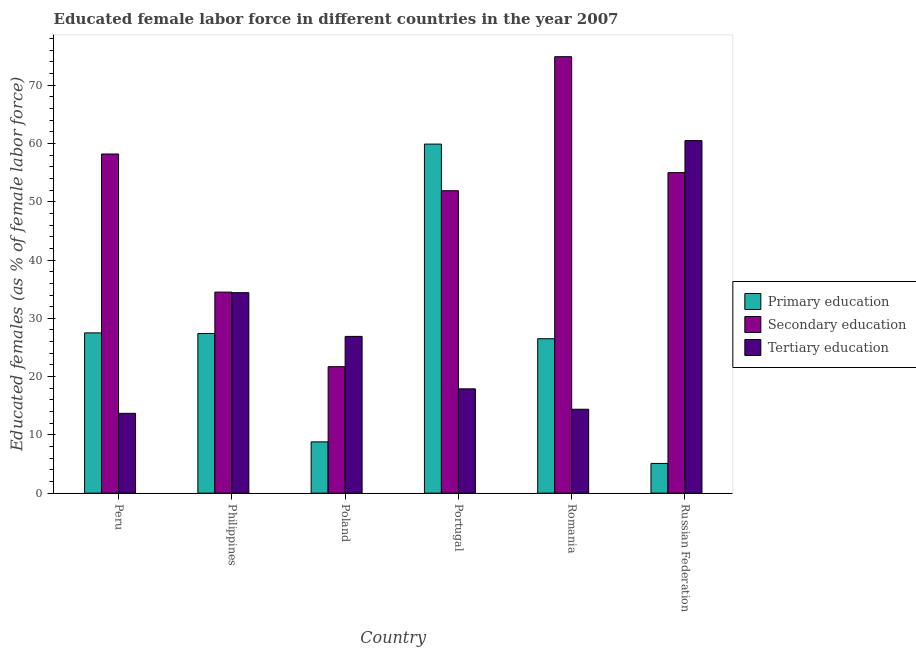Are the number of bars per tick equal to the number of legend labels?
Make the answer very short. Yes. Are the number of bars on each tick of the X-axis equal?
Keep it short and to the point. Yes. How many bars are there on the 5th tick from the right?
Make the answer very short. 3. What is the label of the 2nd group of bars from the left?
Provide a succinct answer. Philippines. What is the percentage of female labor force who received primary education in Philippines?
Your answer should be very brief. 27.4. Across all countries, what is the maximum percentage of female labor force who received secondary education?
Ensure brevity in your answer.  74.9. Across all countries, what is the minimum percentage of female labor force who received secondary education?
Keep it short and to the point. 21.7. In which country was the percentage of female labor force who received secondary education maximum?
Ensure brevity in your answer.  Romania. What is the total percentage of female labor force who received tertiary education in the graph?
Your answer should be very brief. 167.8. What is the difference between the percentage of female labor force who received primary education in Peru and that in Poland?
Give a very brief answer. 18.7. What is the difference between the percentage of female labor force who received primary education in Philippines and the percentage of female labor force who received secondary education in Romania?
Provide a succinct answer. -47.5. What is the average percentage of female labor force who received tertiary education per country?
Your response must be concise. 27.97. What is the difference between the percentage of female labor force who received primary education and percentage of female labor force who received tertiary education in Portugal?
Ensure brevity in your answer.  42. What is the ratio of the percentage of female labor force who received primary education in Poland to that in Russian Federation?
Make the answer very short. 1.73. Is the difference between the percentage of female labor force who received tertiary education in Philippines and Portugal greater than the difference between the percentage of female labor force who received primary education in Philippines and Portugal?
Keep it short and to the point. Yes. What is the difference between the highest and the second highest percentage of female labor force who received tertiary education?
Keep it short and to the point. 26.1. What is the difference between the highest and the lowest percentage of female labor force who received primary education?
Provide a succinct answer. 54.8. What does the 2nd bar from the left in Philippines represents?
Give a very brief answer. Secondary education. What does the 2nd bar from the right in Romania represents?
Provide a short and direct response. Secondary education. Is it the case that in every country, the sum of the percentage of female labor force who received primary education and percentage of female labor force who received secondary education is greater than the percentage of female labor force who received tertiary education?
Offer a very short reply. No. How many bars are there?
Your response must be concise. 18. How many countries are there in the graph?
Ensure brevity in your answer.  6. Are the values on the major ticks of Y-axis written in scientific E-notation?
Your response must be concise. No. Does the graph contain any zero values?
Your answer should be compact. No. Does the graph contain grids?
Your answer should be compact. No. Where does the legend appear in the graph?
Give a very brief answer. Center right. How many legend labels are there?
Ensure brevity in your answer.  3. What is the title of the graph?
Give a very brief answer. Educated female labor force in different countries in the year 2007. Does "Female employers" appear as one of the legend labels in the graph?
Keep it short and to the point. No. What is the label or title of the Y-axis?
Provide a short and direct response. Educated females (as % of female labor force). What is the Educated females (as % of female labor force) in Primary education in Peru?
Your answer should be compact. 27.5. What is the Educated females (as % of female labor force) in Secondary education in Peru?
Give a very brief answer. 58.2. What is the Educated females (as % of female labor force) in Tertiary education in Peru?
Provide a short and direct response. 13.7. What is the Educated females (as % of female labor force) of Primary education in Philippines?
Your answer should be compact. 27.4. What is the Educated females (as % of female labor force) in Secondary education in Philippines?
Provide a short and direct response. 34.5. What is the Educated females (as % of female labor force) in Tertiary education in Philippines?
Ensure brevity in your answer.  34.4. What is the Educated females (as % of female labor force) in Primary education in Poland?
Provide a succinct answer. 8.8. What is the Educated females (as % of female labor force) in Secondary education in Poland?
Your answer should be compact. 21.7. What is the Educated females (as % of female labor force) in Tertiary education in Poland?
Your answer should be very brief. 26.9. What is the Educated females (as % of female labor force) of Primary education in Portugal?
Your response must be concise. 59.9. What is the Educated females (as % of female labor force) of Secondary education in Portugal?
Your answer should be very brief. 51.9. What is the Educated females (as % of female labor force) in Tertiary education in Portugal?
Keep it short and to the point. 17.9. What is the Educated females (as % of female labor force) in Primary education in Romania?
Ensure brevity in your answer.  26.5. What is the Educated females (as % of female labor force) of Secondary education in Romania?
Make the answer very short. 74.9. What is the Educated females (as % of female labor force) in Tertiary education in Romania?
Give a very brief answer. 14.4. What is the Educated females (as % of female labor force) of Primary education in Russian Federation?
Your response must be concise. 5.1. What is the Educated females (as % of female labor force) of Tertiary education in Russian Federation?
Provide a short and direct response. 60.5. Across all countries, what is the maximum Educated females (as % of female labor force) of Primary education?
Your answer should be compact. 59.9. Across all countries, what is the maximum Educated females (as % of female labor force) of Secondary education?
Make the answer very short. 74.9. Across all countries, what is the maximum Educated females (as % of female labor force) in Tertiary education?
Provide a succinct answer. 60.5. Across all countries, what is the minimum Educated females (as % of female labor force) in Primary education?
Offer a very short reply. 5.1. Across all countries, what is the minimum Educated females (as % of female labor force) in Secondary education?
Provide a short and direct response. 21.7. Across all countries, what is the minimum Educated females (as % of female labor force) of Tertiary education?
Your answer should be compact. 13.7. What is the total Educated females (as % of female labor force) of Primary education in the graph?
Make the answer very short. 155.2. What is the total Educated females (as % of female labor force) in Secondary education in the graph?
Offer a very short reply. 296.2. What is the total Educated females (as % of female labor force) of Tertiary education in the graph?
Your answer should be compact. 167.8. What is the difference between the Educated females (as % of female labor force) in Primary education in Peru and that in Philippines?
Give a very brief answer. 0.1. What is the difference between the Educated females (as % of female labor force) in Secondary education in Peru and that in Philippines?
Keep it short and to the point. 23.7. What is the difference between the Educated females (as % of female labor force) in Tertiary education in Peru and that in Philippines?
Your answer should be compact. -20.7. What is the difference between the Educated females (as % of female labor force) of Primary education in Peru and that in Poland?
Ensure brevity in your answer.  18.7. What is the difference between the Educated females (as % of female labor force) of Secondary education in Peru and that in Poland?
Ensure brevity in your answer.  36.5. What is the difference between the Educated females (as % of female labor force) of Primary education in Peru and that in Portugal?
Ensure brevity in your answer.  -32.4. What is the difference between the Educated females (as % of female labor force) of Primary education in Peru and that in Romania?
Give a very brief answer. 1. What is the difference between the Educated females (as % of female labor force) of Secondary education in Peru and that in Romania?
Offer a very short reply. -16.7. What is the difference between the Educated females (as % of female labor force) in Tertiary education in Peru and that in Romania?
Provide a short and direct response. -0.7. What is the difference between the Educated females (as % of female labor force) of Primary education in Peru and that in Russian Federation?
Offer a terse response. 22.4. What is the difference between the Educated females (as % of female labor force) of Secondary education in Peru and that in Russian Federation?
Keep it short and to the point. 3.2. What is the difference between the Educated females (as % of female labor force) of Tertiary education in Peru and that in Russian Federation?
Give a very brief answer. -46.8. What is the difference between the Educated females (as % of female labor force) of Primary education in Philippines and that in Portugal?
Make the answer very short. -32.5. What is the difference between the Educated females (as % of female labor force) of Secondary education in Philippines and that in Portugal?
Ensure brevity in your answer.  -17.4. What is the difference between the Educated females (as % of female labor force) in Tertiary education in Philippines and that in Portugal?
Provide a short and direct response. 16.5. What is the difference between the Educated females (as % of female labor force) in Primary education in Philippines and that in Romania?
Make the answer very short. 0.9. What is the difference between the Educated females (as % of female labor force) of Secondary education in Philippines and that in Romania?
Keep it short and to the point. -40.4. What is the difference between the Educated females (as % of female labor force) of Tertiary education in Philippines and that in Romania?
Ensure brevity in your answer.  20. What is the difference between the Educated females (as % of female labor force) in Primary education in Philippines and that in Russian Federation?
Ensure brevity in your answer.  22.3. What is the difference between the Educated females (as % of female labor force) of Secondary education in Philippines and that in Russian Federation?
Offer a terse response. -20.5. What is the difference between the Educated females (as % of female labor force) in Tertiary education in Philippines and that in Russian Federation?
Make the answer very short. -26.1. What is the difference between the Educated females (as % of female labor force) in Primary education in Poland and that in Portugal?
Ensure brevity in your answer.  -51.1. What is the difference between the Educated females (as % of female labor force) in Secondary education in Poland and that in Portugal?
Provide a short and direct response. -30.2. What is the difference between the Educated females (as % of female labor force) of Tertiary education in Poland and that in Portugal?
Provide a short and direct response. 9. What is the difference between the Educated females (as % of female labor force) of Primary education in Poland and that in Romania?
Provide a short and direct response. -17.7. What is the difference between the Educated females (as % of female labor force) of Secondary education in Poland and that in Romania?
Your answer should be very brief. -53.2. What is the difference between the Educated females (as % of female labor force) of Secondary education in Poland and that in Russian Federation?
Provide a succinct answer. -33.3. What is the difference between the Educated females (as % of female labor force) in Tertiary education in Poland and that in Russian Federation?
Offer a terse response. -33.6. What is the difference between the Educated females (as % of female labor force) in Primary education in Portugal and that in Romania?
Ensure brevity in your answer.  33.4. What is the difference between the Educated females (as % of female labor force) of Secondary education in Portugal and that in Romania?
Offer a very short reply. -23. What is the difference between the Educated females (as % of female labor force) of Primary education in Portugal and that in Russian Federation?
Your answer should be compact. 54.8. What is the difference between the Educated females (as % of female labor force) of Secondary education in Portugal and that in Russian Federation?
Keep it short and to the point. -3.1. What is the difference between the Educated females (as % of female labor force) in Tertiary education in Portugal and that in Russian Federation?
Make the answer very short. -42.6. What is the difference between the Educated females (as % of female labor force) in Primary education in Romania and that in Russian Federation?
Your answer should be compact. 21.4. What is the difference between the Educated females (as % of female labor force) of Secondary education in Romania and that in Russian Federation?
Keep it short and to the point. 19.9. What is the difference between the Educated females (as % of female labor force) of Tertiary education in Romania and that in Russian Federation?
Offer a terse response. -46.1. What is the difference between the Educated females (as % of female labor force) in Primary education in Peru and the Educated females (as % of female labor force) in Secondary education in Philippines?
Your answer should be very brief. -7. What is the difference between the Educated females (as % of female labor force) in Secondary education in Peru and the Educated females (as % of female labor force) in Tertiary education in Philippines?
Provide a short and direct response. 23.8. What is the difference between the Educated females (as % of female labor force) in Secondary education in Peru and the Educated females (as % of female labor force) in Tertiary education in Poland?
Offer a very short reply. 31.3. What is the difference between the Educated females (as % of female labor force) of Primary education in Peru and the Educated females (as % of female labor force) of Secondary education in Portugal?
Make the answer very short. -24.4. What is the difference between the Educated females (as % of female labor force) in Secondary education in Peru and the Educated females (as % of female labor force) in Tertiary education in Portugal?
Provide a succinct answer. 40.3. What is the difference between the Educated females (as % of female labor force) in Primary education in Peru and the Educated females (as % of female labor force) in Secondary education in Romania?
Offer a very short reply. -47.4. What is the difference between the Educated females (as % of female labor force) in Primary education in Peru and the Educated females (as % of female labor force) in Tertiary education in Romania?
Give a very brief answer. 13.1. What is the difference between the Educated females (as % of female labor force) of Secondary education in Peru and the Educated females (as % of female labor force) of Tertiary education in Romania?
Offer a very short reply. 43.8. What is the difference between the Educated females (as % of female labor force) in Primary education in Peru and the Educated females (as % of female labor force) in Secondary education in Russian Federation?
Ensure brevity in your answer.  -27.5. What is the difference between the Educated females (as % of female labor force) of Primary education in Peru and the Educated females (as % of female labor force) of Tertiary education in Russian Federation?
Offer a terse response. -33. What is the difference between the Educated females (as % of female labor force) in Secondary education in Peru and the Educated females (as % of female labor force) in Tertiary education in Russian Federation?
Provide a succinct answer. -2.3. What is the difference between the Educated females (as % of female labor force) of Primary education in Philippines and the Educated females (as % of female labor force) of Secondary education in Poland?
Your answer should be very brief. 5.7. What is the difference between the Educated females (as % of female labor force) in Secondary education in Philippines and the Educated females (as % of female labor force) in Tertiary education in Poland?
Your response must be concise. 7.6. What is the difference between the Educated females (as % of female labor force) in Primary education in Philippines and the Educated females (as % of female labor force) in Secondary education in Portugal?
Provide a short and direct response. -24.5. What is the difference between the Educated females (as % of female labor force) in Secondary education in Philippines and the Educated females (as % of female labor force) in Tertiary education in Portugal?
Your response must be concise. 16.6. What is the difference between the Educated females (as % of female labor force) of Primary education in Philippines and the Educated females (as % of female labor force) of Secondary education in Romania?
Offer a terse response. -47.5. What is the difference between the Educated females (as % of female labor force) in Secondary education in Philippines and the Educated females (as % of female labor force) in Tertiary education in Romania?
Provide a short and direct response. 20.1. What is the difference between the Educated females (as % of female labor force) of Primary education in Philippines and the Educated females (as % of female labor force) of Secondary education in Russian Federation?
Keep it short and to the point. -27.6. What is the difference between the Educated females (as % of female labor force) of Primary education in Philippines and the Educated females (as % of female labor force) of Tertiary education in Russian Federation?
Provide a succinct answer. -33.1. What is the difference between the Educated females (as % of female labor force) of Secondary education in Philippines and the Educated females (as % of female labor force) of Tertiary education in Russian Federation?
Make the answer very short. -26. What is the difference between the Educated females (as % of female labor force) in Primary education in Poland and the Educated females (as % of female labor force) in Secondary education in Portugal?
Your answer should be compact. -43.1. What is the difference between the Educated females (as % of female labor force) of Primary education in Poland and the Educated females (as % of female labor force) of Tertiary education in Portugal?
Keep it short and to the point. -9.1. What is the difference between the Educated females (as % of female labor force) in Secondary education in Poland and the Educated females (as % of female labor force) in Tertiary education in Portugal?
Keep it short and to the point. 3.8. What is the difference between the Educated females (as % of female labor force) of Primary education in Poland and the Educated females (as % of female labor force) of Secondary education in Romania?
Provide a short and direct response. -66.1. What is the difference between the Educated females (as % of female labor force) in Primary education in Poland and the Educated females (as % of female labor force) in Secondary education in Russian Federation?
Provide a succinct answer. -46.2. What is the difference between the Educated females (as % of female labor force) of Primary education in Poland and the Educated females (as % of female labor force) of Tertiary education in Russian Federation?
Your answer should be compact. -51.7. What is the difference between the Educated females (as % of female labor force) in Secondary education in Poland and the Educated females (as % of female labor force) in Tertiary education in Russian Federation?
Make the answer very short. -38.8. What is the difference between the Educated females (as % of female labor force) of Primary education in Portugal and the Educated females (as % of female labor force) of Secondary education in Romania?
Provide a succinct answer. -15. What is the difference between the Educated females (as % of female labor force) in Primary education in Portugal and the Educated females (as % of female labor force) in Tertiary education in Romania?
Your answer should be very brief. 45.5. What is the difference between the Educated females (as % of female labor force) in Secondary education in Portugal and the Educated females (as % of female labor force) in Tertiary education in Romania?
Provide a short and direct response. 37.5. What is the difference between the Educated females (as % of female labor force) in Primary education in Portugal and the Educated females (as % of female labor force) in Tertiary education in Russian Federation?
Your answer should be very brief. -0.6. What is the difference between the Educated females (as % of female labor force) in Primary education in Romania and the Educated females (as % of female labor force) in Secondary education in Russian Federation?
Offer a very short reply. -28.5. What is the difference between the Educated females (as % of female labor force) of Primary education in Romania and the Educated females (as % of female labor force) of Tertiary education in Russian Federation?
Your response must be concise. -34. What is the average Educated females (as % of female labor force) in Primary education per country?
Provide a succinct answer. 25.87. What is the average Educated females (as % of female labor force) in Secondary education per country?
Keep it short and to the point. 49.37. What is the average Educated females (as % of female labor force) in Tertiary education per country?
Offer a very short reply. 27.97. What is the difference between the Educated females (as % of female labor force) in Primary education and Educated females (as % of female labor force) in Secondary education in Peru?
Ensure brevity in your answer.  -30.7. What is the difference between the Educated females (as % of female labor force) in Primary education and Educated females (as % of female labor force) in Tertiary education in Peru?
Make the answer very short. 13.8. What is the difference between the Educated females (as % of female labor force) of Secondary education and Educated females (as % of female labor force) of Tertiary education in Peru?
Provide a short and direct response. 44.5. What is the difference between the Educated females (as % of female labor force) in Primary education and Educated females (as % of female labor force) in Secondary education in Poland?
Provide a succinct answer. -12.9. What is the difference between the Educated females (as % of female labor force) in Primary education and Educated females (as % of female labor force) in Tertiary education in Poland?
Give a very brief answer. -18.1. What is the difference between the Educated females (as % of female labor force) in Secondary education and Educated females (as % of female labor force) in Tertiary education in Poland?
Your response must be concise. -5.2. What is the difference between the Educated females (as % of female labor force) in Primary education and Educated females (as % of female labor force) in Secondary education in Romania?
Provide a succinct answer. -48.4. What is the difference between the Educated females (as % of female labor force) in Secondary education and Educated females (as % of female labor force) in Tertiary education in Romania?
Your response must be concise. 60.5. What is the difference between the Educated females (as % of female labor force) of Primary education and Educated females (as % of female labor force) of Secondary education in Russian Federation?
Your response must be concise. -49.9. What is the difference between the Educated females (as % of female labor force) of Primary education and Educated females (as % of female labor force) of Tertiary education in Russian Federation?
Your response must be concise. -55.4. What is the difference between the Educated females (as % of female labor force) of Secondary education and Educated females (as % of female labor force) of Tertiary education in Russian Federation?
Offer a terse response. -5.5. What is the ratio of the Educated females (as % of female labor force) of Secondary education in Peru to that in Philippines?
Keep it short and to the point. 1.69. What is the ratio of the Educated females (as % of female labor force) in Tertiary education in Peru to that in Philippines?
Give a very brief answer. 0.4. What is the ratio of the Educated females (as % of female labor force) of Primary education in Peru to that in Poland?
Provide a succinct answer. 3.12. What is the ratio of the Educated females (as % of female labor force) in Secondary education in Peru to that in Poland?
Keep it short and to the point. 2.68. What is the ratio of the Educated females (as % of female labor force) of Tertiary education in Peru to that in Poland?
Your answer should be very brief. 0.51. What is the ratio of the Educated females (as % of female labor force) in Primary education in Peru to that in Portugal?
Offer a very short reply. 0.46. What is the ratio of the Educated females (as % of female labor force) of Secondary education in Peru to that in Portugal?
Offer a terse response. 1.12. What is the ratio of the Educated females (as % of female labor force) in Tertiary education in Peru to that in Portugal?
Provide a succinct answer. 0.77. What is the ratio of the Educated females (as % of female labor force) of Primary education in Peru to that in Romania?
Provide a succinct answer. 1.04. What is the ratio of the Educated females (as % of female labor force) in Secondary education in Peru to that in Romania?
Your answer should be compact. 0.78. What is the ratio of the Educated females (as % of female labor force) in Tertiary education in Peru to that in Romania?
Make the answer very short. 0.95. What is the ratio of the Educated females (as % of female labor force) of Primary education in Peru to that in Russian Federation?
Offer a terse response. 5.39. What is the ratio of the Educated females (as % of female labor force) of Secondary education in Peru to that in Russian Federation?
Give a very brief answer. 1.06. What is the ratio of the Educated females (as % of female labor force) in Tertiary education in Peru to that in Russian Federation?
Provide a short and direct response. 0.23. What is the ratio of the Educated females (as % of female labor force) in Primary education in Philippines to that in Poland?
Offer a terse response. 3.11. What is the ratio of the Educated females (as % of female labor force) of Secondary education in Philippines to that in Poland?
Your answer should be compact. 1.59. What is the ratio of the Educated females (as % of female labor force) of Tertiary education in Philippines to that in Poland?
Your answer should be compact. 1.28. What is the ratio of the Educated females (as % of female labor force) in Primary education in Philippines to that in Portugal?
Your answer should be very brief. 0.46. What is the ratio of the Educated females (as % of female labor force) of Secondary education in Philippines to that in Portugal?
Provide a short and direct response. 0.66. What is the ratio of the Educated females (as % of female labor force) of Tertiary education in Philippines to that in Portugal?
Your answer should be compact. 1.92. What is the ratio of the Educated females (as % of female labor force) of Primary education in Philippines to that in Romania?
Provide a succinct answer. 1.03. What is the ratio of the Educated females (as % of female labor force) of Secondary education in Philippines to that in Romania?
Ensure brevity in your answer.  0.46. What is the ratio of the Educated females (as % of female labor force) of Tertiary education in Philippines to that in Romania?
Your answer should be very brief. 2.39. What is the ratio of the Educated females (as % of female labor force) in Primary education in Philippines to that in Russian Federation?
Offer a terse response. 5.37. What is the ratio of the Educated females (as % of female labor force) in Secondary education in Philippines to that in Russian Federation?
Offer a terse response. 0.63. What is the ratio of the Educated females (as % of female labor force) in Tertiary education in Philippines to that in Russian Federation?
Offer a terse response. 0.57. What is the ratio of the Educated females (as % of female labor force) in Primary education in Poland to that in Portugal?
Provide a succinct answer. 0.15. What is the ratio of the Educated females (as % of female labor force) in Secondary education in Poland to that in Portugal?
Provide a succinct answer. 0.42. What is the ratio of the Educated females (as % of female labor force) in Tertiary education in Poland to that in Portugal?
Give a very brief answer. 1.5. What is the ratio of the Educated females (as % of female labor force) of Primary education in Poland to that in Romania?
Ensure brevity in your answer.  0.33. What is the ratio of the Educated females (as % of female labor force) in Secondary education in Poland to that in Romania?
Make the answer very short. 0.29. What is the ratio of the Educated females (as % of female labor force) of Tertiary education in Poland to that in Romania?
Provide a short and direct response. 1.87. What is the ratio of the Educated females (as % of female labor force) in Primary education in Poland to that in Russian Federation?
Keep it short and to the point. 1.73. What is the ratio of the Educated females (as % of female labor force) of Secondary education in Poland to that in Russian Federation?
Offer a very short reply. 0.39. What is the ratio of the Educated females (as % of female labor force) of Tertiary education in Poland to that in Russian Federation?
Ensure brevity in your answer.  0.44. What is the ratio of the Educated females (as % of female labor force) of Primary education in Portugal to that in Romania?
Ensure brevity in your answer.  2.26. What is the ratio of the Educated females (as % of female labor force) in Secondary education in Portugal to that in Romania?
Keep it short and to the point. 0.69. What is the ratio of the Educated females (as % of female labor force) of Tertiary education in Portugal to that in Romania?
Offer a terse response. 1.24. What is the ratio of the Educated females (as % of female labor force) in Primary education in Portugal to that in Russian Federation?
Give a very brief answer. 11.75. What is the ratio of the Educated females (as % of female labor force) of Secondary education in Portugal to that in Russian Federation?
Provide a succinct answer. 0.94. What is the ratio of the Educated females (as % of female labor force) of Tertiary education in Portugal to that in Russian Federation?
Offer a very short reply. 0.3. What is the ratio of the Educated females (as % of female labor force) of Primary education in Romania to that in Russian Federation?
Offer a very short reply. 5.2. What is the ratio of the Educated females (as % of female labor force) of Secondary education in Romania to that in Russian Federation?
Provide a short and direct response. 1.36. What is the ratio of the Educated females (as % of female labor force) of Tertiary education in Romania to that in Russian Federation?
Provide a short and direct response. 0.24. What is the difference between the highest and the second highest Educated females (as % of female labor force) in Primary education?
Make the answer very short. 32.4. What is the difference between the highest and the second highest Educated females (as % of female labor force) of Tertiary education?
Offer a terse response. 26.1. What is the difference between the highest and the lowest Educated females (as % of female labor force) in Primary education?
Your response must be concise. 54.8. What is the difference between the highest and the lowest Educated females (as % of female labor force) of Secondary education?
Make the answer very short. 53.2. What is the difference between the highest and the lowest Educated females (as % of female labor force) in Tertiary education?
Make the answer very short. 46.8. 